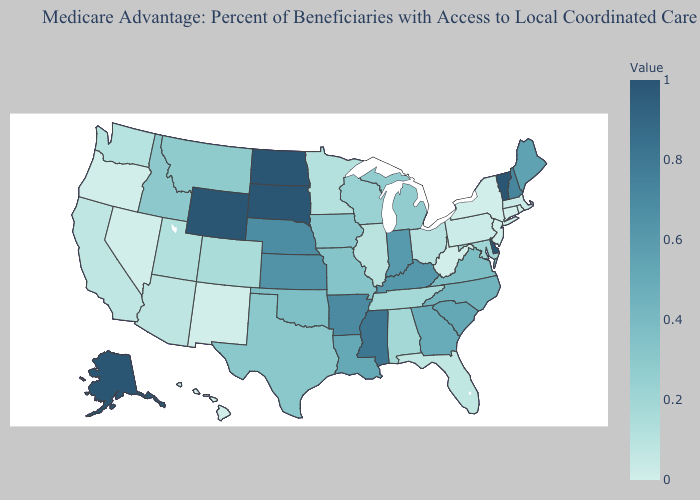Does Kentucky have a lower value than Oklahoma?
Quick response, please. No. Among the states that border Minnesota , does South Dakota have the lowest value?
Write a very short answer. No. Does North Dakota have the highest value in the MidWest?
Quick response, please. Yes. Among the states that border New Jersey , does Pennsylvania have the lowest value?
Concise answer only. No. Which states have the highest value in the USA?
Concise answer only. Alaska, Delaware, North Dakota, South Dakota, Vermont, Wyoming. Which states have the lowest value in the South?
Be succinct. West Virginia. Does Arizona have the highest value in the USA?
Answer briefly. No. Is the legend a continuous bar?
Be succinct. Yes. Does Idaho have the lowest value in the USA?
Be succinct. No. 